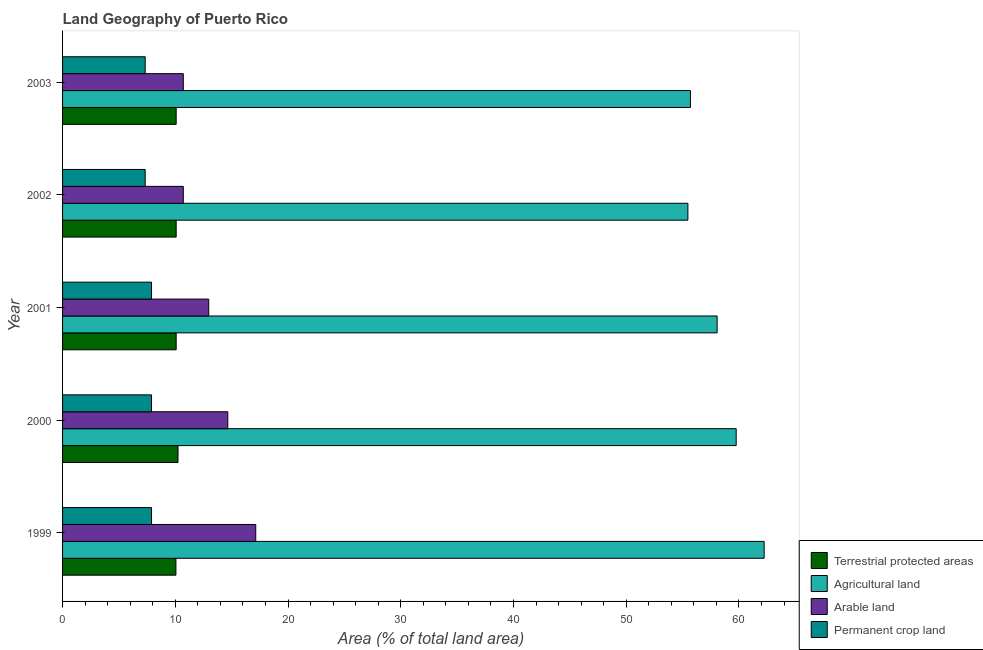How many different coloured bars are there?
Provide a short and direct response. 4. Are the number of bars per tick equal to the number of legend labels?
Your answer should be compact. Yes. Are the number of bars on each tick of the Y-axis equal?
Provide a short and direct response. Yes. How many bars are there on the 5th tick from the bottom?
Your answer should be very brief. 4. What is the label of the 2nd group of bars from the top?
Your answer should be very brief. 2002. What is the percentage of area under arable land in 1999?
Your answer should be very brief. 17.14. Across all years, what is the maximum percentage of area under agricultural land?
Make the answer very short. 62.23. Across all years, what is the minimum percentage of area under arable land?
Your answer should be compact. 10.71. What is the total percentage of land under terrestrial protection in the graph?
Your answer should be very brief. 50.53. What is the difference between the percentage of area under agricultural land in 1999 and that in 2002?
Offer a terse response. 6.76. What is the difference between the percentage of area under permanent crop land in 2003 and the percentage of area under arable land in 1999?
Offer a terse response. -9.81. What is the average percentage of area under arable land per year?
Your response must be concise. 13.24. In the year 2000, what is the difference between the percentage of area under permanent crop land and percentage of land under terrestrial protection?
Give a very brief answer. -2.35. In how many years, is the percentage of area under arable land greater than 36 %?
Your answer should be very brief. 0. Is the difference between the percentage of area under arable land in 2001 and 2003 greater than the difference between the percentage of area under permanent crop land in 2001 and 2003?
Offer a terse response. Yes. What is the difference between the highest and the lowest percentage of area under agricultural land?
Your response must be concise. 6.76. In how many years, is the percentage of area under agricultural land greater than the average percentage of area under agricultural land taken over all years?
Your answer should be compact. 2. What does the 2nd bar from the top in 2003 represents?
Your answer should be very brief. Arable land. What does the 1st bar from the bottom in 2000 represents?
Make the answer very short. Terrestrial protected areas. Is it the case that in every year, the sum of the percentage of land under terrestrial protection and percentage of area under agricultural land is greater than the percentage of area under arable land?
Keep it short and to the point. Yes. How many bars are there?
Provide a succinct answer. 20. Are all the bars in the graph horizontal?
Provide a succinct answer. Yes. Where does the legend appear in the graph?
Your answer should be very brief. Bottom right. How many legend labels are there?
Provide a succinct answer. 4. How are the legend labels stacked?
Give a very brief answer. Vertical. What is the title of the graph?
Give a very brief answer. Land Geography of Puerto Rico. Does "Miscellaneous expenses" appear as one of the legend labels in the graph?
Ensure brevity in your answer.  No. What is the label or title of the X-axis?
Offer a very short reply. Area (% of total land area). What is the Area (% of total land area) in Terrestrial protected areas in 1999?
Make the answer very short. 10.05. What is the Area (% of total land area) in Agricultural land in 1999?
Offer a terse response. 62.23. What is the Area (% of total land area) in Arable land in 1999?
Keep it short and to the point. 17.14. What is the Area (% of total land area) of Permanent crop land in 1999?
Give a very brief answer. 7.89. What is the Area (% of total land area) of Terrestrial protected areas in 2000?
Ensure brevity in your answer.  10.24. What is the Area (% of total land area) of Agricultural land in 2000?
Offer a very short reply. 59.75. What is the Area (% of total land area) in Arable land in 2000?
Offer a very short reply. 14.66. What is the Area (% of total land area) of Permanent crop land in 2000?
Your answer should be very brief. 7.89. What is the Area (% of total land area) of Terrestrial protected areas in 2001?
Your answer should be compact. 10.08. What is the Area (% of total land area) of Agricultural land in 2001?
Offer a very short reply. 58.06. What is the Area (% of total land area) of Arable land in 2001?
Offer a very short reply. 12.97. What is the Area (% of total land area) of Permanent crop land in 2001?
Ensure brevity in your answer.  7.89. What is the Area (% of total land area) in Terrestrial protected areas in 2002?
Keep it short and to the point. 10.08. What is the Area (% of total land area) in Agricultural land in 2002?
Offer a very short reply. 55.47. What is the Area (% of total land area) of Arable land in 2002?
Keep it short and to the point. 10.71. What is the Area (% of total land area) of Permanent crop land in 2002?
Make the answer very short. 7.33. What is the Area (% of total land area) of Terrestrial protected areas in 2003?
Ensure brevity in your answer.  10.08. What is the Area (% of total land area) in Agricultural land in 2003?
Provide a short and direct response. 55.69. What is the Area (% of total land area) of Arable land in 2003?
Your answer should be very brief. 10.71. What is the Area (% of total land area) in Permanent crop land in 2003?
Your response must be concise. 7.33. Across all years, what is the maximum Area (% of total land area) in Terrestrial protected areas?
Ensure brevity in your answer.  10.24. Across all years, what is the maximum Area (% of total land area) in Agricultural land?
Your answer should be compact. 62.23. Across all years, what is the maximum Area (% of total land area) of Arable land?
Provide a succinct answer. 17.14. Across all years, what is the maximum Area (% of total land area) of Permanent crop land?
Provide a short and direct response. 7.89. Across all years, what is the minimum Area (% of total land area) in Terrestrial protected areas?
Make the answer very short. 10.05. Across all years, what is the minimum Area (% of total land area) of Agricultural land?
Provide a succinct answer. 55.47. Across all years, what is the minimum Area (% of total land area) of Arable land?
Give a very brief answer. 10.71. Across all years, what is the minimum Area (% of total land area) of Permanent crop land?
Keep it short and to the point. 7.33. What is the total Area (% of total land area) in Terrestrial protected areas in the graph?
Ensure brevity in your answer.  50.53. What is the total Area (% of total land area) of Agricultural land in the graph?
Your response must be concise. 291.21. What is the total Area (% of total land area) of Arable land in the graph?
Offer a terse response. 66.18. What is the total Area (% of total land area) in Permanent crop land in the graph?
Your answer should be compact. 38.33. What is the difference between the Area (% of total land area) in Terrestrial protected areas in 1999 and that in 2000?
Give a very brief answer. -0.18. What is the difference between the Area (% of total land area) in Agricultural land in 1999 and that in 2000?
Your answer should be compact. 2.48. What is the difference between the Area (% of total land area) in Arable land in 1999 and that in 2000?
Keep it short and to the point. 2.48. What is the difference between the Area (% of total land area) of Terrestrial protected areas in 1999 and that in 2001?
Your response must be concise. -0.02. What is the difference between the Area (% of total land area) in Agricultural land in 1999 and that in 2001?
Your response must be concise. 4.17. What is the difference between the Area (% of total land area) in Arable land in 1999 and that in 2001?
Keep it short and to the point. 4.17. What is the difference between the Area (% of total land area) in Permanent crop land in 1999 and that in 2001?
Offer a very short reply. 0. What is the difference between the Area (% of total land area) in Terrestrial protected areas in 1999 and that in 2002?
Keep it short and to the point. -0.02. What is the difference between the Area (% of total land area) of Agricultural land in 1999 and that in 2002?
Provide a short and direct response. 6.76. What is the difference between the Area (% of total land area) in Arable land in 1999 and that in 2002?
Your response must be concise. 6.43. What is the difference between the Area (% of total land area) of Permanent crop land in 1999 and that in 2002?
Offer a very short reply. 0.56. What is the difference between the Area (% of total land area) of Terrestrial protected areas in 1999 and that in 2003?
Make the answer very short. -0.02. What is the difference between the Area (% of total land area) of Agricultural land in 1999 and that in 2003?
Offer a very short reply. 6.54. What is the difference between the Area (% of total land area) in Arable land in 1999 and that in 2003?
Ensure brevity in your answer.  6.43. What is the difference between the Area (% of total land area) of Permanent crop land in 1999 and that in 2003?
Your response must be concise. 0.56. What is the difference between the Area (% of total land area) of Terrestrial protected areas in 2000 and that in 2001?
Provide a succinct answer. 0.16. What is the difference between the Area (% of total land area) in Agricultural land in 2000 and that in 2001?
Your answer should be very brief. 1.69. What is the difference between the Area (% of total land area) in Arable land in 2000 and that in 2001?
Provide a succinct answer. 1.69. What is the difference between the Area (% of total land area) in Permanent crop land in 2000 and that in 2001?
Your answer should be very brief. 0. What is the difference between the Area (% of total land area) of Terrestrial protected areas in 2000 and that in 2002?
Your response must be concise. 0.16. What is the difference between the Area (% of total land area) of Agricultural land in 2000 and that in 2002?
Offer a terse response. 4.28. What is the difference between the Area (% of total land area) of Arable land in 2000 and that in 2002?
Ensure brevity in your answer.  3.95. What is the difference between the Area (% of total land area) in Permanent crop land in 2000 and that in 2002?
Ensure brevity in your answer.  0.56. What is the difference between the Area (% of total land area) in Terrestrial protected areas in 2000 and that in 2003?
Keep it short and to the point. 0.16. What is the difference between the Area (% of total land area) in Agricultural land in 2000 and that in 2003?
Offer a terse response. 4.06. What is the difference between the Area (% of total land area) of Arable land in 2000 and that in 2003?
Give a very brief answer. 3.95. What is the difference between the Area (% of total land area) in Permanent crop land in 2000 and that in 2003?
Offer a very short reply. 0.56. What is the difference between the Area (% of total land area) of Agricultural land in 2001 and that in 2002?
Your answer should be compact. 2.59. What is the difference between the Area (% of total land area) in Arable land in 2001 and that in 2002?
Provide a succinct answer. 2.25. What is the difference between the Area (% of total land area) in Permanent crop land in 2001 and that in 2002?
Offer a terse response. 0.56. What is the difference between the Area (% of total land area) in Terrestrial protected areas in 2001 and that in 2003?
Make the answer very short. 0. What is the difference between the Area (% of total land area) of Agricultural land in 2001 and that in 2003?
Give a very brief answer. 2.37. What is the difference between the Area (% of total land area) of Arable land in 2001 and that in 2003?
Provide a short and direct response. 2.25. What is the difference between the Area (% of total land area) in Permanent crop land in 2001 and that in 2003?
Make the answer very short. 0.56. What is the difference between the Area (% of total land area) of Terrestrial protected areas in 2002 and that in 2003?
Make the answer very short. 0. What is the difference between the Area (% of total land area) in Agricultural land in 2002 and that in 2003?
Provide a succinct answer. -0.23. What is the difference between the Area (% of total land area) of Terrestrial protected areas in 1999 and the Area (% of total land area) of Agricultural land in 2000?
Your answer should be compact. -49.7. What is the difference between the Area (% of total land area) of Terrestrial protected areas in 1999 and the Area (% of total land area) of Arable land in 2000?
Make the answer very short. -4.6. What is the difference between the Area (% of total land area) in Terrestrial protected areas in 1999 and the Area (% of total land area) in Permanent crop land in 2000?
Provide a succinct answer. 2.16. What is the difference between the Area (% of total land area) in Agricultural land in 1999 and the Area (% of total land area) in Arable land in 2000?
Offer a terse response. 47.58. What is the difference between the Area (% of total land area) in Agricultural land in 1999 and the Area (% of total land area) in Permanent crop land in 2000?
Provide a succinct answer. 54.34. What is the difference between the Area (% of total land area) of Arable land in 1999 and the Area (% of total land area) of Permanent crop land in 2000?
Offer a very short reply. 9.24. What is the difference between the Area (% of total land area) of Terrestrial protected areas in 1999 and the Area (% of total land area) of Agricultural land in 2001?
Your answer should be compact. -48.01. What is the difference between the Area (% of total land area) in Terrestrial protected areas in 1999 and the Area (% of total land area) in Arable land in 2001?
Offer a very short reply. -2.91. What is the difference between the Area (% of total land area) of Terrestrial protected areas in 1999 and the Area (% of total land area) of Permanent crop land in 2001?
Provide a succinct answer. 2.16. What is the difference between the Area (% of total land area) of Agricultural land in 1999 and the Area (% of total land area) of Arable land in 2001?
Make the answer very short. 49.27. What is the difference between the Area (% of total land area) of Agricultural land in 1999 and the Area (% of total land area) of Permanent crop land in 2001?
Your answer should be compact. 54.34. What is the difference between the Area (% of total land area) in Arable land in 1999 and the Area (% of total land area) in Permanent crop land in 2001?
Give a very brief answer. 9.24. What is the difference between the Area (% of total land area) in Terrestrial protected areas in 1999 and the Area (% of total land area) in Agricultural land in 2002?
Provide a succinct answer. -45.41. What is the difference between the Area (% of total land area) of Terrestrial protected areas in 1999 and the Area (% of total land area) of Arable land in 2002?
Keep it short and to the point. -0.66. What is the difference between the Area (% of total land area) of Terrestrial protected areas in 1999 and the Area (% of total land area) of Permanent crop land in 2002?
Your answer should be very brief. 2.73. What is the difference between the Area (% of total land area) in Agricultural land in 1999 and the Area (% of total land area) in Arable land in 2002?
Provide a short and direct response. 51.52. What is the difference between the Area (% of total land area) of Agricultural land in 1999 and the Area (% of total land area) of Permanent crop land in 2002?
Give a very brief answer. 54.9. What is the difference between the Area (% of total land area) of Arable land in 1999 and the Area (% of total land area) of Permanent crop land in 2002?
Offer a very short reply. 9.81. What is the difference between the Area (% of total land area) in Terrestrial protected areas in 1999 and the Area (% of total land area) in Agricultural land in 2003?
Give a very brief answer. -45.64. What is the difference between the Area (% of total land area) of Terrestrial protected areas in 1999 and the Area (% of total land area) of Arable land in 2003?
Keep it short and to the point. -0.66. What is the difference between the Area (% of total land area) of Terrestrial protected areas in 1999 and the Area (% of total land area) of Permanent crop land in 2003?
Your answer should be compact. 2.73. What is the difference between the Area (% of total land area) in Agricultural land in 1999 and the Area (% of total land area) in Arable land in 2003?
Give a very brief answer. 51.52. What is the difference between the Area (% of total land area) in Agricultural land in 1999 and the Area (% of total land area) in Permanent crop land in 2003?
Ensure brevity in your answer.  54.9. What is the difference between the Area (% of total land area) in Arable land in 1999 and the Area (% of total land area) in Permanent crop land in 2003?
Offer a terse response. 9.81. What is the difference between the Area (% of total land area) in Terrestrial protected areas in 2000 and the Area (% of total land area) in Agricultural land in 2001?
Ensure brevity in your answer.  -47.82. What is the difference between the Area (% of total land area) in Terrestrial protected areas in 2000 and the Area (% of total land area) in Arable land in 2001?
Your response must be concise. -2.73. What is the difference between the Area (% of total land area) in Terrestrial protected areas in 2000 and the Area (% of total land area) in Permanent crop land in 2001?
Ensure brevity in your answer.  2.35. What is the difference between the Area (% of total land area) of Agricultural land in 2000 and the Area (% of total land area) of Arable land in 2001?
Keep it short and to the point. 46.79. What is the difference between the Area (% of total land area) in Agricultural land in 2000 and the Area (% of total land area) in Permanent crop land in 2001?
Your response must be concise. 51.86. What is the difference between the Area (% of total land area) of Arable land in 2000 and the Area (% of total land area) of Permanent crop land in 2001?
Make the answer very short. 6.76. What is the difference between the Area (% of total land area) in Terrestrial protected areas in 2000 and the Area (% of total land area) in Agricultural land in 2002?
Make the answer very short. -45.23. What is the difference between the Area (% of total land area) of Terrestrial protected areas in 2000 and the Area (% of total land area) of Arable land in 2002?
Your answer should be compact. -0.47. What is the difference between the Area (% of total land area) of Terrestrial protected areas in 2000 and the Area (% of total land area) of Permanent crop land in 2002?
Provide a succinct answer. 2.91. What is the difference between the Area (% of total land area) of Agricultural land in 2000 and the Area (% of total land area) of Arable land in 2002?
Your answer should be very brief. 49.04. What is the difference between the Area (% of total land area) in Agricultural land in 2000 and the Area (% of total land area) in Permanent crop land in 2002?
Provide a succinct answer. 52.42. What is the difference between the Area (% of total land area) of Arable land in 2000 and the Area (% of total land area) of Permanent crop land in 2002?
Offer a terse response. 7.33. What is the difference between the Area (% of total land area) in Terrestrial protected areas in 2000 and the Area (% of total land area) in Agricultural land in 2003?
Your answer should be compact. -45.45. What is the difference between the Area (% of total land area) in Terrestrial protected areas in 2000 and the Area (% of total land area) in Arable land in 2003?
Provide a succinct answer. -0.47. What is the difference between the Area (% of total land area) of Terrestrial protected areas in 2000 and the Area (% of total land area) of Permanent crop land in 2003?
Keep it short and to the point. 2.91. What is the difference between the Area (% of total land area) in Agricultural land in 2000 and the Area (% of total land area) in Arable land in 2003?
Provide a succinct answer. 49.04. What is the difference between the Area (% of total land area) of Agricultural land in 2000 and the Area (% of total land area) of Permanent crop land in 2003?
Provide a succinct answer. 52.42. What is the difference between the Area (% of total land area) of Arable land in 2000 and the Area (% of total land area) of Permanent crop land in 2003?
Provide a succinct answer. 7.33. What is the difference between the Area (% of total land area) in Terrestrial protected areas in 2001 and the Area (% of total land area) in Agricultural land in 2002?
Your response must be concise. -45.39. What is the difference between the Area (% of total land area) in Terrestrial protected areas in 2001 and the Area (% of total land area) in Arable land in 2002?
Your answer should be very brief. -0.63. What is the difference between the Area (% of total land area) of Terrestrial protected areas in 2001 and the Area (% of total land area) of Permanent crop land in 2002?
Make the answer very short. 2.75. What is the difference between the Area (% of total land area) in Agricultural land in 2001 and the Area (% of total land area) in Arable land in 2002?
Your answer should be compact. 47.35. What is the difference between the Area (% of total land area) of Agricultural land in 2001 and the Area (% of total land area) of Permanent crop land in 2002?
Keep it short and to the point. 50.73. What is the difference between the Area (% of total land area) in Arable land in 2001 and the Area (% of total land area) in Permanent crop land in 2002?
Your answer should be very brief. 5.64. What is the difference between the Area (% of total land area) in Terrestrial protected areas in 2001 and the Area (% of total land area) in Agricultural land in 2003?
Your answer should be very brief. -45.62. What is the difference between the Area (% of total land area) of Terrestrial protected areas in 2001 and the Area (% of total land area) of Arable land in 2003?
Offer a very short reply. -0.63. What is the difference between the Area (% of total land area) of Terrestrial protected areas in 2001 and the Area (% of total land area) of Permanent crop land in 2003?
Provide a succinct answer. 2.75. What is the difference between the Area (% of total land area) of Agricultural land in 2001 and the Area (% of total land area) of Arable land in 2003?
Offer a terse response. 47.35. What is the difference between the Area (% of total land area) in Agricultural land in 2001 and the Area (% of total land area) in Permanent crop land in 2003?
Ensure brevity in your answer.  50.73. What is the difference between the Area (% of total land area) of Arable land in 2001 and the Area (% of total land area) of Permanent crop land in 2003?
Your response must be concise. 5.64. What is the difference between the Area (% of total land area) in Terrestrial protected areas in 2002 and the Area (% of total land area) in Agricultural land in 2003?
Your answer should be compact. -45.62. What is the difference between the Area (% of total land area) of Terrestrial protected areas in 2002 and the Area (% of total land area) of Arable land in 2003?
Your response must be concise. -0.63. What is the difference between the Area (% of total land area) in Terrestrial protected areas in 2002 and the Area (% of total land area) in Permanent crop land in 2003?
Provide a short and direct response. 2.75. What is the difference between the Area (% of total land area) of Agricultural land in 2002 and the Area (% of total land area) of Arable land in 2003?
Keep it short and to the point. 44.76. What is the difference between the Area (% of total land area) in Agricultural land in 2002 and the Area (% of total land area) in Permanent crop land in 2003?
Your answer should be compact. 48.14. What is the difference between the Area (% of total land area) in Arable land in 2002 and the Area (% of total land area) in Permanent crop land in 2003?
Provide a succinct answer. 3.38. What is the average Area (% of total land area) of Terrestrial protected areas per year?
Provide a short and direct response. 10.11. What is the average Area (% of total land area) of Agricultural land per year?
Provide a succinct answer. 58.24. What is the average Area (% of total land area) in Arable land per year?
Provide a short and direct response. 13.24. What is the average Area (% of total land area) of Permanent crop land per year?
Offer a terse response. 7.67. In the year 1999, what is the difference between the Area (% of total land area) in Terrestrial protected areas and Area (% of total land area) in Agricultural land?
Make the answer very short. -52.18. In the year 1999, what is the difference between the Area (% of total land area) of Terrestrial protected areas and Area (% of total land area) of Arable land?
Offer a terse response. -7.08. In the year 1999, what is the difference between the Area (% of total land area) in Terrestrial protected areas and Area (% of total land area) in Permanent crop land?
Keep it short and to the point. 2.16. In the year 1999, what is the difference between the Area (% of total land area) of Agricultural land and Area (% of total land area) of Arable land?
Offer a terse response. 45.1. In the year 1999, what is the difference between the Area (% of total land area) in Agricultural land and Area (% of total land area) in Permanent crop land?
Give a very brief answer. 54.34. In the year 1999, what is the difference between the Area (% of total land area) of Arable land and Area (% of total land area) of Permanent crop land?
Offer a very short reply. 9.24. In the year 2000, what is the difference between the Area (% of total land area) of Terrestrial protected areas and Area (% of total land area) of Agricultural land?
Your response must be concise. -49.51. In the year 2000, what is the difference between the Area (% of total land area) in Terrestrial protected areas and Area (% of total land area) in Arable land?
Make the answer very short. -4.42. In the year 2000, what is the difference between the Area (% of total land area) in Terrestrial protected areas and Area (% of total land area) in Permanent crop land?
Keep it short and to the point. 2.35. In the year 2000, what is the difference between the Area (% of total land area) of Agricultural land and Area (% of total land area) of Arable land?
Ensure brevity in your answer.  45.1. In the year 2000, what is the difference between the Area (% of total land area) of Agricultural land and Area (% of total land area) of Permanent crop land?
Provide a succinct answer. 51.86. In the year 2000, what is the difference between the Area (% of total land area) in Arable land and Area (% of total land area) in Permanent crop land?
Your response must be concise. 6.76. In the year 2001, what is the difference between the Area (% of total land area) of Terrestrial protected areas and Area (% of total land area) of Agricultural land?
Your response must be concise. -47.98. In the year 2001, what is the difference between the Area (% of total land area) in Terrestrial protected areas and Area (% of total land area) in Arable land?
Your response must be concise. -2.89. In the year 2001, what is the difference between the Area (% of total land area) of Terrestrial protected areas and Area (% of total land area) of Permanent crop land?
Make the answer very short. 2.19. In the year 2001, what is the difference between the Area (% of total land area) of Agricultural land and Area (% of total land area) of Arable land?
Make the answer very short. 45.1. In the year 2001, what is the difference between the Area (% of total land area) of Agricultural land and Area (% of total land area) of Permanent crop land?
Offer a terse response. 50.17. In the year 2001, what is the difference between the Area (% of total land area) of Arable land and Area (% of total land area) of Permanent crop land?
Provide a succinct answer. 5.07. In the year 2002, what is the difference between the Area (% of total land area) of Terrestrial protected areas and Area (% of total land area) of Agricultural land?
Provide a succinct answer. -45.39. In the year 2002, what is the difference between the Area (% of total land area) of Terrestrial protected areas and Area (% of total land area) of Arable land?
Ensure brevity in your answer.  -0.63. In the year 2002, what is the difference between the Area (% of total land area) of Terrestrial protected areas and Area (% of total land area) of Permanent crop land?
Provide a succinct answer. 2.75. In the year 2002, what is the difference between the Area (% of total land area) of Agricultural land and Area (% of total land area) of Arable land?
Your answer should be very brief. 44.76. In the year 2002, what is the difference between the Area (% of total land area) in Agricultural land and Area (% of total land area) in Permanent crop land?
Provide a short and direct response. 48.14. In the year 2002, what is the difference between the Area (% of total land area) in Arable land and Area (% of total land area) in Permanent crop land?
Give a very brief answer. 3.38. In the year 2003, what is the difference between the Area (% of total land area) in Terrestrial protected areas and Area (% of total land area) in Agricultural land?
Offer a terse response. -45.62. In the year 2003, what is the difference between the Area (% of total land area) in Terrestrial protected areas and Area (% of total land area) in Arable land?
Keep it short and to the point. -0.63. In the year 2003, what is the difference between the Area (% of total land area) in Terrestrial protected areas and Area (% of total land area) in Permanent crop land?
Keep it short and to the point. 2.75. In the year 2003, what is the difference between the Area (% of total land area) in Agricultural land and Area (% of total land area) in Arable land?
Provide a short and direct response. 44.98. In the year 2003, what is the difference between the Area (% of total land area) in Agricultural land and Area (% of total land area) in Permanent crop land?
Ensure brevity in your answer.  48.37. In the year 2003, what is the difference between the Area (% of total land area) in Arable land and Area (% of total land area) in Permanent crop land?
Your response must be concise. 3.38. What is the ratio of the Area (% of total land area) of Terrestrial protected areas in 1999 to that in 2000?
Make the answer very short. 0.98. What is the ratio of the Area (% of total land area) in Agricultural land in 1999 to that in 2000?
Your answer should be compact. 1.04. What is the ratio of the Area (% of total land area) of Arable land in 1999 to that in 2000?
Offer a very short reply. 1.17. What is the ratio of the Area (% of total land area) of Terrestrial protected areas in 1999 to that in 2001?
Provide a short and direct response. 1. What is the ratio of the Area (% of total land area) in Agricultural land in 1999 to that in 2001?
Provide a short and direct response. 1.07. What is the ratio of the Area (% of total land area) in Arable land in 1999 to that in 2001?
Offer a very short reply. 1.32. What is the ratio of the Area (% of total land area) in Permanent crop land in 1999 to that in 2001?
Give a very brief answer. 1. What is the ratio of the Area (% of total land area) in Terrestrial protected areas in 1999 to that in 2002?
Provide a succinct answer. 1. What is the ratio of the Area (% of total land area) in Agricultural land in 1999 to that in 2002?
Offer a terse response. 1.12. What is the ratio of the Area (% of total land area) of Arable land in 1999 to that in 2002?
Offer a terse response. 1.6. What is the ratio of the Area (% of total land area) in Terrestrial protected areas in 1999 to that in 2003?
Give a very brief answer. 1. What is the ratio of the Area (% of total land area) in Agricultural land in 1999 to that in 2003?
Offer a terse response. 1.12. What is the ratio of the Area (% of total land area) of Arable land in 1999 to that in 2003?
Your response must be concise. 1.6. What is the ratio of the Area (% of total land area) of Terrestrial protected areas in 2000 to that in 2001?
Provide a short and direct response. 1.02. What is the ratio of the Area (% of total land area) of Agricultural land in 2000 to that in 2001?
Keep it short and to the point. 1.03. What is the ratio of the Area (% of total land area) in Arable land in 2000 to that in 2001?
Offer a very short reply. 1.13. What is the ratio of the Area (% of total land area) of Terrestrial protected areas in 2000 to that in 2002?
Your answer should be very brief. 1.02. What is the ratio of the Area (% of total land area) of Agricultural land in 2000 to that in 2002?
Your answer should be compact. 1.08. What is the ratio of the Area (% of total land area) in Arable land in 2000 to that in 2002?
Make the answer very short. 1.37. What is the ratio of the Area (% of total land area) in Permanent crop land in 2000 to that in 2002?
Offer a terse response. 1.08. What is the ratio of the Area (% of total land area) of Agricultural land in 2000 to that in 2003?
Your answer should be compact. 1.07. What is the ratio of the Area (% of total land area) of Arable land in 2000 to that in 2003?
Your answer should be compact. 1.37. What is the ratio of the Area (% of total land area) of Permanent crop land in 2000 to that in 2003?
Your answer should be compact. 1.08. What is the ratio of the Area (% of total land area) of Agricultural land in 2001 to that in 2002?
Ensure brevity in your answer.  1.05. What is the ratio of the Area (% of total land area) of Arable land in 2001 to that in 2002?
Make the answer very short. 1.21. What is the ratio of the Area (% of total land area) of Agricultural land in 2001 to that in 2003?
Keep it short and to the point. 1.04. What is the ratio of the Area (% of total land area) of Arable land in 2001 to that in 2003?
Your response must be concise. 1.21. What is the ratio of the Area (% of total land area) in Terrestrial protected areas in 2002 to that in 2003?
Give a very brief answer. 1. What is the ratio of the Area (% of total land area) in Arable land in 2002 to that in 2003?
Offer a terse response. 1. What is the difference between the highest and the second highest Area (% of total land area) of Terrestrial protected areas?
Make the answer very short. 0.16. What is the difference between the highest and the second highest Area (% of total land area) in Agricultural land?
Provide a succinct answer. 2.48. What is the difference between the highest and the second highest Area (% of total land area) in Arable land?
Your answer should be compact. 2.48. What is the difference between the highest and the lowest Area (% of total land area) in Terrestrial protected areas?
Ensure brevity in your answer.  0.18. What is the difference between the highest and the lowest Area (% of total land area) in Agricultural land?
Your response must be concise. 6.76. What is the difference between the highest and the lowest Area (% of total land area) of Arable land?
Offer a very short reply. 6.43. What is the difference between the highest and the lowest Area (% of total land area) of Permanent crop land?
Make the answer very short. 0.56. 